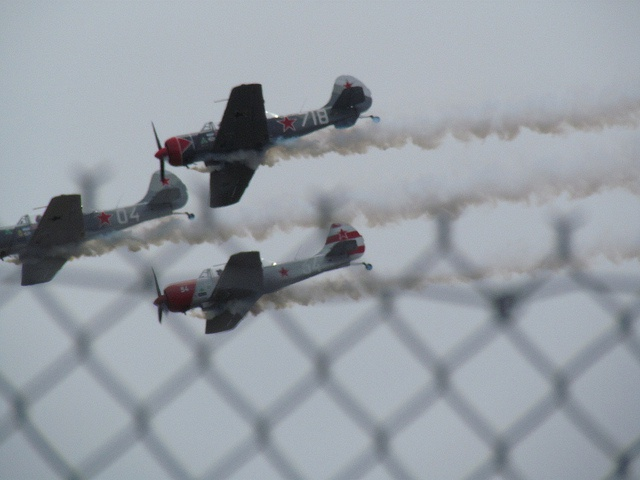Describe the objects in this image and their specific colors. I can see airplane in darkgray, black, gray, and darkblue tones, airplane in darkgray, black, gray, and maroon tones, and airplane in darkgray, black, gray, and purple tones in this image. 